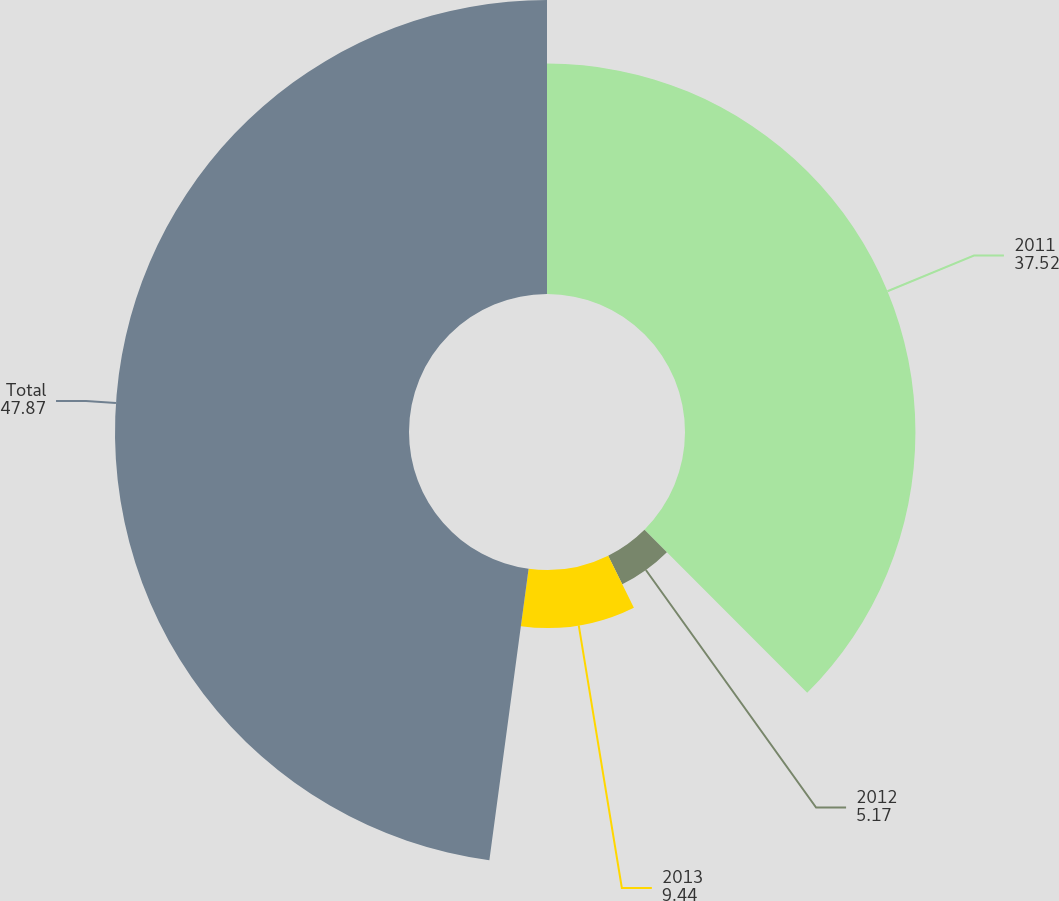Convert chart to OTSL. <chart><loc_0><loc_0><loc_500><loc_500><pie_chart><fcel>2011<fcel>2012<fcel>2013<fcel>Total<nl><fcel>37.52%<fcel>5.17%<fcel>9.44%<fcel>47.87%<nl></chart> 